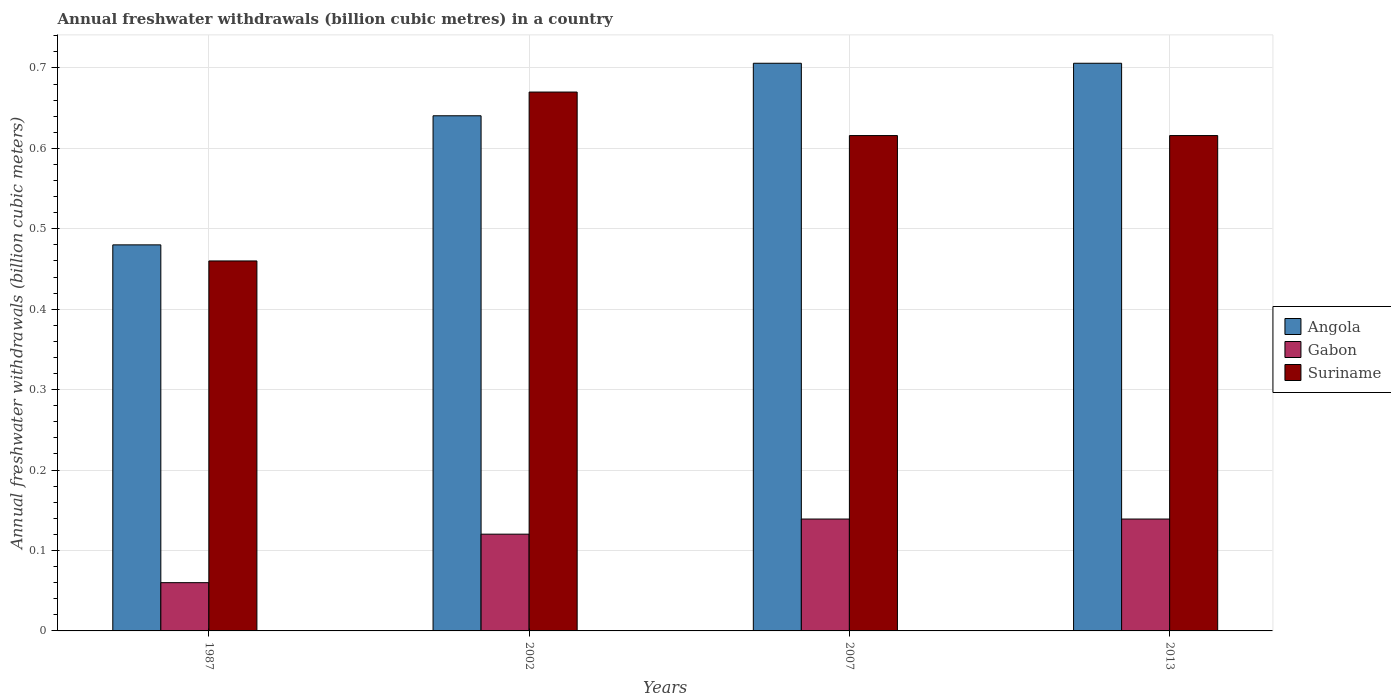How many different coloured bars are there?
Offer a very short reply. 3. Are the number of bars per tick equal to the number of legend labels?
Give a very brief answer. Yes. Are the number of bars on each tick of the X-axis equal?
Offer a very short reply. Yes. What is the annual freshwater withdrawals in Suriname in 1987?
Keep it short and to the point. 0.46. Across all years, what is the maximum annual freshwater withdrawals in Angola?
Your answer should be very brief. 0.71. Across all years, what is the minimum annual freshwater withdrawals in Suriname?
Make the answer very short. 0.46. In which year was the annual freshwater withdrawals in Gabon maximum?
Make the answer very short. 2007. What is the total annual freshwater withdrawals in Suriname in the graph?
Give a very brief answer. 2.36. What is the difference between the annual freshwater withdrawals in Angola in 1987 and that in 2013?
Your answer should be compact. -0.23. What is the difference between the annual freshwater withdrawals in Suriname in 2007 and the annual freshwater withdrawals in Angola in 2002?
Make the answer very short. -0.02. What is the average annual freshwater withdrawals in Gabon per year?
Offer a very short reply. 0.11. In the year 1987, what is the difference between the annual freshwater withdrawals in Suriname and annual freshwater withdrawals in Angola?
Keep it short and to the point. -0.02. In how many years, is the annual freshwater withdrawals in Suriname greater than 0.52 billion cubic meters?
Ensure brevity in your answer.  3. What is the ratio of the annual freshwater withdrawals in Gabon in 2002 to that in 2007?
Provide a short and direct response. 0.86. Is the annual freshwater withdrawals in Gabon in 2007 less than that in 2013?
Offer a very short reply. No. Is the difference between the annual freshwater withdrawals in Suriname in 1987 and 2013 greater than the difference between the annual freshwater withdrawals in Angola in 1987 and 2013?
Make the answer very short. Yes. What is the difference between the highest and the second highest annual freshwater withdrawals in Gabon?
Provide a succinct answer. 0. What is the difference between the highest and the lowest annual freshwater withdrawals in Angola?
Provide a short and direct response. 0.23. In how many years, is the annual freshwater withdrawals in Angola greater than the average annual freshwater withdrawals in Angola taken over all years?
Make the answer very short. 3. What does the 3rd bar from the left in 2007 represents?
Give a very brief answer. Suriname. What does the 2nd bar from the right in 2013 represents?
Provide a succinct answer. Gabon. What is the difference between two consecutive major ticks on the Y-axis?
Make the answer very short. 0.1. Does the graph contain any zero values?
Make the answer very short. No. Does the graph contain grids?
Ensure brevity in your answer.  Yes. Where does the legend appear in the graph?
Offer a very short reply. Center right. How many legend labels are there?
Provide a short and direct response. 3. How are the legend labels stacked?
Ensure brevity in your answer.  Vertical. What is the title of the graph?
Ensure brevity in your answer.  Annual freshwater withdrawals (billion cubic metres) in a country. What is the label or title of the X-axis?
Provide a short and direct response. Years. What is the label or title of the Y-axis?
Give a very brief answer. Annual freshwater withdrawals (billion cubic meters). What is the Annual freshwater withdrawals (billion cubic meters) of Angola in 1987?
Ensure brevity in your answer.  0.48. What is the Annual freshwater withdrawals (billion cubic meters) in Gabon in 1987?
Offer a terse response. 0.06. What is the Annual freshwater withdrawals (billion cubic meters) of Suriname in 1987?
Give a very brief answer. 0.46. What is the Annual freshwater withdrawals (billion cubic meters) of Angola in 2002?
Offer a terse response. 0.64. What is the Annual freshwater withdrawals (billion cubic meters) in Gabon in 2002?
Provide a short and direct response. 0.12. What is the Annual freshwater withdrawals (billion cubic meters) of Suriname in 2002?
Your answer should be compact. 0.67. What is the Annual freshwater withdrawals (billion cubic meters) of Angola in 2007?
Your answer should be compact. 0.71. What is the Annual freshwater withdrawals (billion cubic meters) of Gabon in 2007?
Ensure brevity in your answer.  0.14. What is the Annual freshwater withdrawals (billion cubic meters) of Suriname in 2007?
Offer a very short reply. 0.62. What is the Annual freshwater withdrawals (billion cubic meters) in Angola in 2013?
Keep it short and to the point. 0.71. What is the Annual freshwater withdrawals (billion cubic meters) of Gabon in 2013?
Keep it short and to the point. 0.14. What is the Annual freshwater withdrawals (billion cubic meters) of Suriname in 2013?
Offer a terse response. 0.62. Across all years, what is the maximum Annual freshwater withdrawals (billion cubic meters) in Angola?
Offer a very short reply. 0.71. Across all years, what is the maximum Annual freshwater withdrawals (billion cubic meters) of Gabon?
Your answer should be compact. 0.14. Across all years, what is the maximum Annual freshwater withdrawals (billion cubic meters) in Suriname?
Your answer should be very brief. 0.67. Across all years, what is the minimum Annual freshwater withdrawals (billion cubic meters) in Angola?
Offer a terse response. 0.48. Across all years, what is the minimum Annual freshwater withdrawals (billion cubic meters) of Suriname?
Provide a succinct answer. 0.46. What is the total Annual freshwater withdrawals (billion cubic meters) of Angola in the graph?
Provide a succinct answer. 2.53. What is the total Annual freshwater withdrawals (billion cubic meters) of Gabon in the graph?
Your answer should be compact. 0.46. What is the total Annual freshwater withdrawals (billion cubic meters) of Suriname in the graph?
Provide a short and direct response. 2.36. What is the difference between the Annual freshwater withdrawals (billion cubic meters) of Angola in 1987 and that in 2002?
Your response must be concise. -0.16. What is the difference between the Annual freshwater withdrawals (billion cubic meters) in Gabon in 1987 and that in 2002?
Provide a succinct answer. -0.06. What is the difference between the Annual freshwater withdrawals (billion cubic meters) of Suriname in 1987 and that in 2002?
Keep it short and to the point. -0.21. What is the difference between the Annual freshwater withdrawals (billion cubic meters) in Angola in 1987 and that in 2007?
Your answer should be compact. -0.23. What is the difference between the Annual freshwater withdrawals (billion cubic meters) in Gabon in 1987 and that in 2007?
Keep it short and to the point. -0.08. What is the difference between the Annual freshwater withdrawals (billion cubic meters) in Suriname in 1987 and that in 2007?
Offer a terse response. -0.16. What is the difference between the Annual freshwater withdrawals (billion cubic meters) of Angola in 1987 and that in 2013?
Your response must be concise. -0.23. What is the difference between the Annual freshwater withdrawals (billion cubic meters) of Gabon in 1987 and that in 2013?
Your answer should be very brief. -0.08. What is the difference between the Annual freshwater withdrawals (billion cubic meters) in Suriname in 1987 and that in 2013?
Provide a succinct answer. -0.16. What is the difference between the Annual freshwater withdrawals (billion cubic meters) of Angola in 2002 and that in 2007?
Give a very brief answer. -0.07. What is the difference between the Annual freshwater withdrawals (billion cubic meters) of Gabon in 2002 and that in 2007?
Offer a very short reply. -0.02. What is the difference between the Annual freshwater withdrawals (billion cubic meters) of Suriname in 2002 and that in 2007?
Offer a very short reply. 0.05. What is the difference between the Annual freshwater withdrawals (billion cubic meters) of Angola in 2002 and that in 2013?
Make the answer very short. -0.07. What is the difference between the Annual freshwater withdrawals (billion cubic meters) in Gabon in 2002 and that in 2013?
Your response must be concise. -0.02. What is the difference between the Annual freshwater withdrawals (billion cubic meters) in Suriname in 2002 and that in 2013?
Offer a terse response. 0.05. What is the difference between the Annual freshwater withdrawals (billion cubic meters) of Angola in 2007 and that in 2013?
Your answer should be very brief. 0. What is the difference between the Annual freshwater withdrawals (billion cubic meters) of Gabon in 2007 and that in 2013?
Provide a succinct answer. 0. What is the difference between the Annual freshwater withdrawals (billion cubic meters) of Angola in 1987 and the Annual freshwater withdrawals (billion cubic meters) of Gabon in 2002?
Give a very brief answer. 0.36. What is the difference between the Annual freshwater withdrawals (billion cubic meters) of Angola in 1987 and the Annual freshwater withdrawals (billion cubic meters) of Suriname in 2002?
Your response must be concise. -0.19. What is the difference between the Annual freshwater withdrawals (billion cubic meters) of Gabon in 1987 and the Annual freshwater withdrawals (billion cubic meters) of Suriname in 2002?
Provide a succinct answer. -0.61. What is the difference between the Annual freshwater withdrawals (billion cubic meters) in Angola in 1987 and the Annual freshwater withdrawals (billion cubic meters) in Gabon in 2007?
Make the answer very short. 0.34. What is the difference between the Annual freshwater withdrawals (billion cubic meters) of Angola in 1987 and the Annual freshwater withdrawals (billion cubic meters) of Suriname in 2007?
Keep it short and to the point. -0.14. What is the difference between the Annual freshwater withdrawals (billion cubic meters) of Gabon in 1987 and the Annual freshwater withdrawals (billion cubic meters) of Suriname in 2007?
Your answer should be very brief. -0.56. What is the difference between the Annual freshwater withdrawals (billion cubic meters) in Angola in 1987 and the Annual freshwater withdrawals (billion cubic meters) in Gabon in 2013?
Offer a very short reply. 0.34. What is the difference between the Annual freshwater withdrawals (billion cubic meters) of Angola in 1987 and the Annual freshwater withdrawals (billion cubic meters) of Suriname in 2013?
Provide a succinct answer. -0.14. What is the difference between the Annual freshwater withdrawals (billion cubic meters) of Gabon in 1987 and the Annual freshwater withdrawals (billion cubic meters) of Suriname in 2013?
Your answer should be compact. -0.56. What is the difference between the Annual freshwater withdrawals (billion cubic meters) of Angola in 2002 and the Annual freshwater withdrawals (billion cubic meters) of Gabon in 2007?
Provide a succinct answer. 0.5. What is the difference between the Annual freshwater withdrawals (billion cubic meters) in Angola in 2002 and the Annual freshwater withdrawals (billion cubic meters) in Suriname in 2007?
Ensure brevity in your answer.  0.02. What is the difference between the Annual freshwater withdrawals (billion cubic meters) in Gabon in 2002 and the Annual freshwater withdrawals (billion cubic meters) in Suriname in 2007?
Make the answer very short. -0.5. What is the difference between the Annual freshwater withdrawals (billion cubic meters) in Angola in 2002 and the Annual freshwater withdrawals (billion cubic meters) in Gabon in 2013?
Your answer should be compact. 0.5. What is the difference between the Annual freshwater withdrawals (billion cubic meters) of Angola in 2002 and the Annual freshwater withdrawals (billion cubic meters) of Suriname in 2013?
Keep it short and to the point. 0.02. What is the difference between the Annual freshwater withdrawals (billion cubic meters) of Gabon in 2002 and the Annual freshwater withdrawals (billion cubic meters) of Suriname in 2013?
Offer a very short reply. -0.5. What is the difference between the Annual freshwater withdrawals (billion cubic meters) in Angola in 2007 and the Annual freshwater withdrawals (billion cubic meters) in Gabon in 2013?
Provide a succinct answer. 0.57. What is the difference between the Annual freshwater withdrawals (billion cubic meters) in Angola in 2007 and the Annual freshwater withdrawals (billion cubic meters) in Suriname in 2013?
Offer a terse response. 0.09. What is the difference between the Annual freshwater withdrawals (billion cubic meters) of Gabon in 2007 and the Annual freshwater withdrawals (billion cubic meters) of Suriname in 2013?
Your answer should be compact. -0.48. What is the average Annual freshwater withdrawals (billion cubic meters) of Angola per year?
Offer a terse response. 0.63. What is the average Annual freshwater withdrawals (billion cubic meters) of Gabon per year?
Provide a short and direct response. 0.11. What is the average Annual freshwater withdrawals (billion cubic meters) in Suriname per year?
Ensure brevity in your answer.  0.59. In the year 1987, what is the difference between the Annual freshwater withdrawals (billion cubic meters) in Angola and Annual freshwater withdrawals (billion cubic meters) in Gabon?
Ensure brevity in your answer.  0.42. In the year 1987, what is the difference between the Annual freshwater withdrawals (billion cubic meters) of Angola and Annual freshwater withdrawals (billion cubic meters) of Suriname?
Keep it short and to the point. 0.02. In the year 1987, what is the difference between the Annual freshwater withdrawals (billion cubic meters) of Gabon and Annual freshwater withdrawals (billion cubic meters) of Suriname?
Keep it short and to the point. -0.4. In the year 2002, what is the difference between the Annual freshwater withdrawals (billion cubic meters) in Angola and Annual freshwater withdrawals (billion cubic meters) in Gabon?
Offer a very short reply. 0.52. In the year 2002, what is the difference between the Annual freshwater withdrawals (billion cubic meters) of Angola and Annual freshwater withdrawals (billion cubic meters) of Suriname?
Keep it short and to the point. -0.03. In the year 2002, what is the difference between the Annual freshwater withdrawals (billion cubic meters) of Gabon and Annual freshwater withdrawals (billion cubic meters) of Suriname?
Ensure brevity in your answer.  -0.55. In the year 2007, what is the difference between the Annual freshwater withdrawals (billion cubic meters) in Angola and Annual freshwater withdrawals (billion cubic meters) in Gabon?
Your response must be concise. 0.57. In the year 2007, what is the difference between the Annual freshwater withdrawals (billion cubic meters) in Angola and Annual freshwater withdrawals (billion cubic meters) in Suriname?
Ensure brevity in your answer.  0.09. In the year 2007, what is the difference between the Annual freshwater withdrawals (billion cubic meters) in Gabon and Annual freshwater withdrawals (billion cubic meters) in Suriname?
Give a very brief answer. -0.48. In the year 2013, what is the difference between the Annual freshwater withdrawals (billion cubic meters) of Angola and Annual freshwater withdrawals (billion cubic meters) of Gabon?
Make the answer very short. 0.57. In the year 2013, what is the difference between the Annual freshwater withdrawals (billion cubic meters) of Angola and Annual freshwater withdrawals (billion cubic meters) of Suriname?
Provide a short and direct response. 0.09. In the year 2013, what is the difference between the Annual freshwater withdrawals (billion cubic meters) of Gabon and Annual freshwater withdrawals (billion cubic meters) of Suriname?
Ensure brevity in your answer.  -0.48. What is the ratio of the Annual freshwater withdrawals (billion cubic meters) in Angola in 1987 to that in 2002?
Offer a terse response. 0.75. What is the ratio of the Annual freshwater withdrawals (billion cubic meters) in Gabon in 1987 to that in 2002?
Make the answer very short. 0.5. What is the ratio of the Annual freshwater withdrawals (billion cubic meters) of Suriname in 1987 to that in 2002?
Your answer should be very brief. 0.69. What is the ratio of the Annual freshwater withdrawals (billion cubic meters) in Angola in 1987 to that in 2007?
Offer a terse response. 0.68. What is the ratio of the Annual freshwater withdrawals (billion cubic meters) of Gabon in 1987 to that in 2007?
Provide a succinct answer. 0.43. What is the ratio of the Annual freshwater withdrawals (billion cubic meters) of Suriname in 1987 to that in 2007?
Your answer should be very brief. 0.75. What is the ratio of the Annual freshwater withdrawals (billion cubic meters) in Angola in 1987 to that in 2013?
Make the answer very short. 0.68. What is the ratio of the Annual freshwater withdrawals (billion cubic meters) in Gabon in 1987 to that in 2013?
Your answer should be compact. 0.43. What is the ratio of the Annual freshwater withdrawals (billion cubic meters) in Suriname in 1987 to that in 2013?
Offer a very short reply. 0.75. What is the ratio of the Annual freshwater withdrawals (billion cubic meters) in Angola in 2002 to that in 2007?
Provide a succinct answer. 0.91. What is the ratio of the Annual freshwater withdrawals (billion cubic meters) of Gabon in 2002 to that in 2007?
Give a very brief answer. 0.86. What is the ratio of the Annual freshwater withdrawals (billion cubic meters) of Suriname in 2002 to that in 2007?
Give a very brief answer. 1.09. What is the ratio of the Annual freshwater withdrawals (billion cubic meters) of Angola in 2002 to that in 2013?
Provide a short and direct response. 0.91. What is the ratio of the Annual freshwater withdrawals (billion cubic meters) in Gabon in 2002 to that in 2013?
Offer a terse response. 0.86. What is the ratio of the Annual freshwater withdrawals (billion cubic meters) of Suriname in 2002 to that in 2013?
Ensure brevity in your answer.  1.09. What is the ratio of the Annual freshwater withdrawals (billion cubic meters) of Angola in 2007 to that in 2013?
Give a very brief answer. 1. What is the ratio of the Annual freshwater withdrawals (billion cubic meters) of Suriname in 2007 to that in 2013?
Offer a terse response. 1. What is the difference between the highest and the second highest Annual freshwater withdrawals (billion cubic meters) in Angola?
Your response must be concise. 0. What is the difference between the highest and the second highest Annual freshwater withdrawals (billion cubic meters) of Gabon?
Give a very brief answer. 0. What is the difference between the highest and the second highest Annual freshwater withdrawals (billion cubic meters) in Suriname?
Provide a short and direct response. 0.05. What is the difference between the highest and the lowest Annual freshwater withdrawals (billion cubic meters) in Angola?
Give a very brief answer. 0.23. What is the difference between the highest and the lowest Annual freshwater withdrawals (billion cubic meters) in Gabon?
Your response must be concise. 0.08. What is the difference between the highest and the lowest Annual freshwater withdrawals (billion cubic meters) in Suriname?
Offer a very short reply. 0.21. 